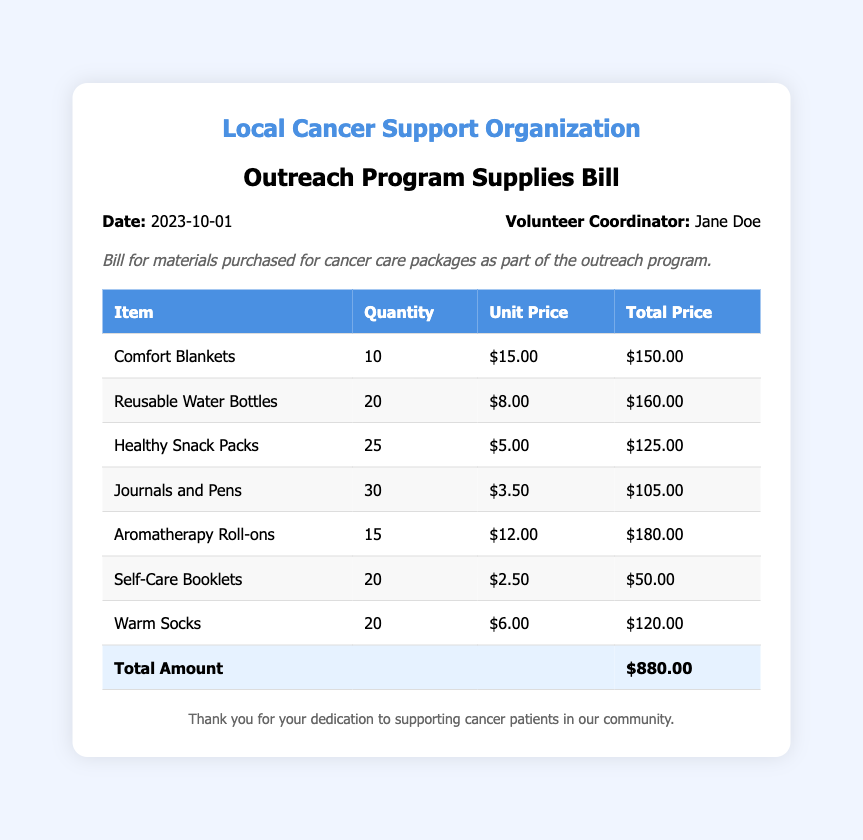What is the date of the bill? The date of the bill is explicitly stated in the document as the date when the bill was created.
Answer: 2023-10-01 Who is the volunteer coordinator? The document provides the name of the volunteer coordinator responsible for the bill.
Answer: Jane Doe How many comfort blankets were purchased? The quantity of comfort blankets can be found in the itemized list of materials.
Answer: 10 What is the total amount of the bill? The total amount is the sum of all item totals listed in the document.
Answer: $880.00 What is the unit price of reusable water bottles? The document lists the unit price alongside the quantity in the bill's itemized section.
Answer: $8.00 How many different types of items were purchased? The total number of different items can be counted from the line items provided in the table.
Answer: 7 What item has the highest total price? This requires examining the total price for each item to determine which one is the highest.
Answer: Aromatherapy Roll-ons What item was purchased in the highest quantity? By comparing the quantities listed for each item, we can find the one with the highest count.
Answer: Journals and Pens What color is the organization name in the header? The document specifies the color used for the organization name in its styling.
Answer: #4a90e2 